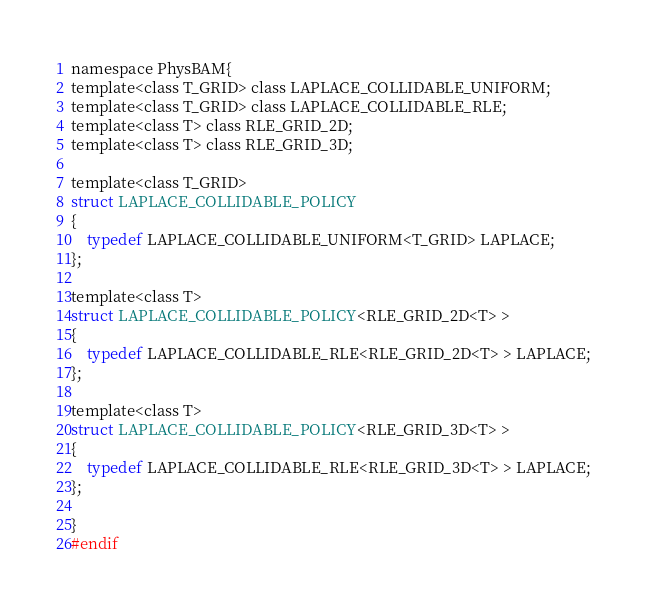<code> <loc_0><loc_0><loc_500><loc_500><_C_>
namespace PhysBAM{
template<class T_GRID> class LAPLACE_COLLIDABLE_UNIFORM;
template<class T_GRID> class LAPLACE_COLLIDABLE_RLE;
template<class T> class RLE_GRID_2D;
template<class T> class RLE_GRID_3D;

template<class T_GRID>
struct LAPLACE_COLLIDABLE_POLICY
{
    typedef LAPLACE_COLLIDABLE_UNIFORM<T_GRID> LAPLACE;
};

template<class T>
struct LAPLACE_COLLIDABLE_POLICY<RLE_GRID_2D<T> >
{
    typedef LAPLACE_COLLIDABLE_RLE<RLE_GRID_2D<T> > LAPLACE;
};

template<class T>
struct LAPLACE_COLLIDABLE_POLICY<RLE_GRID_3D<T> >
{
    typedef LAPLACE_COLLIDABLE_RLE<RLE_GRID_3D<T> > LAPLACE;
};

}
#endif
</code> 